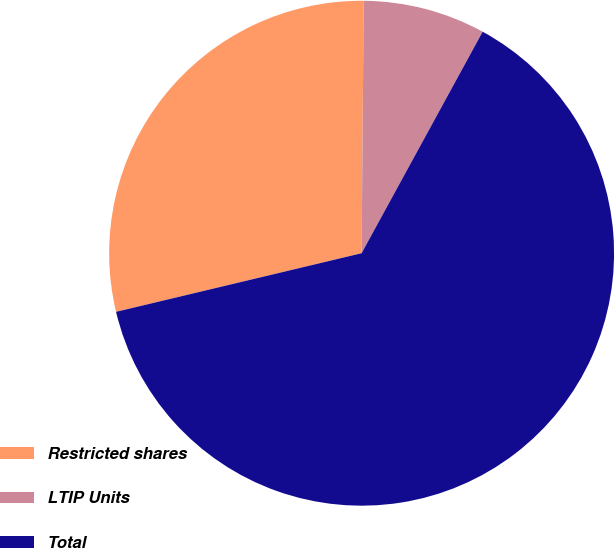Convert chart to OTSL. <chart><loc_0><loc_0><loc_500><loc_500><pie_chart><fcel>Restricted shares<fcel>LTIP Units<fcel>Total<nl><fcel>28.86%<fcel>7.83%<fcel>63.31%<nl></chart> 